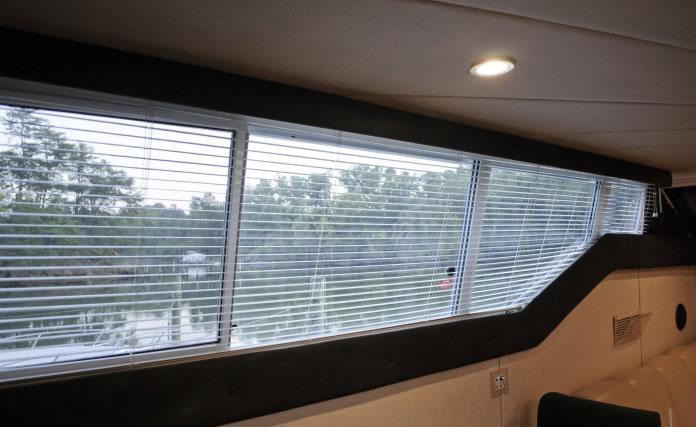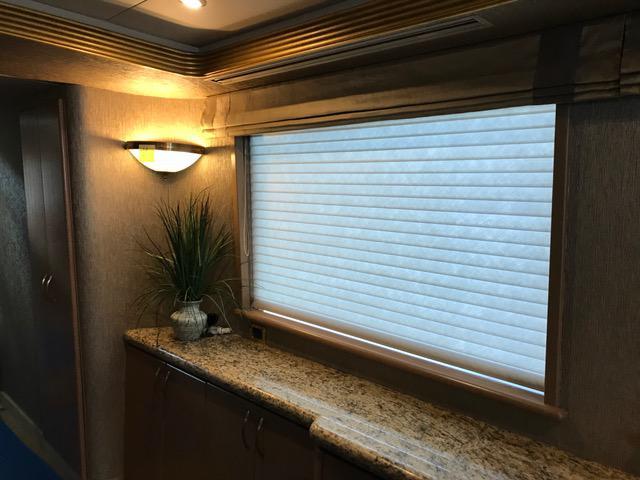The first image is the image on the left, the second image is the image on the right. Assess this claim about the two images: "There is a total of five windows.". Correct or not? Answer yes or no. Yes. The first image is the image on the left, the second image is the image on the right. Examine the images to the left and right. Is the description "The window area in the image on the left has lights that are switched on." accurate? Answer yes or no. Yes. 